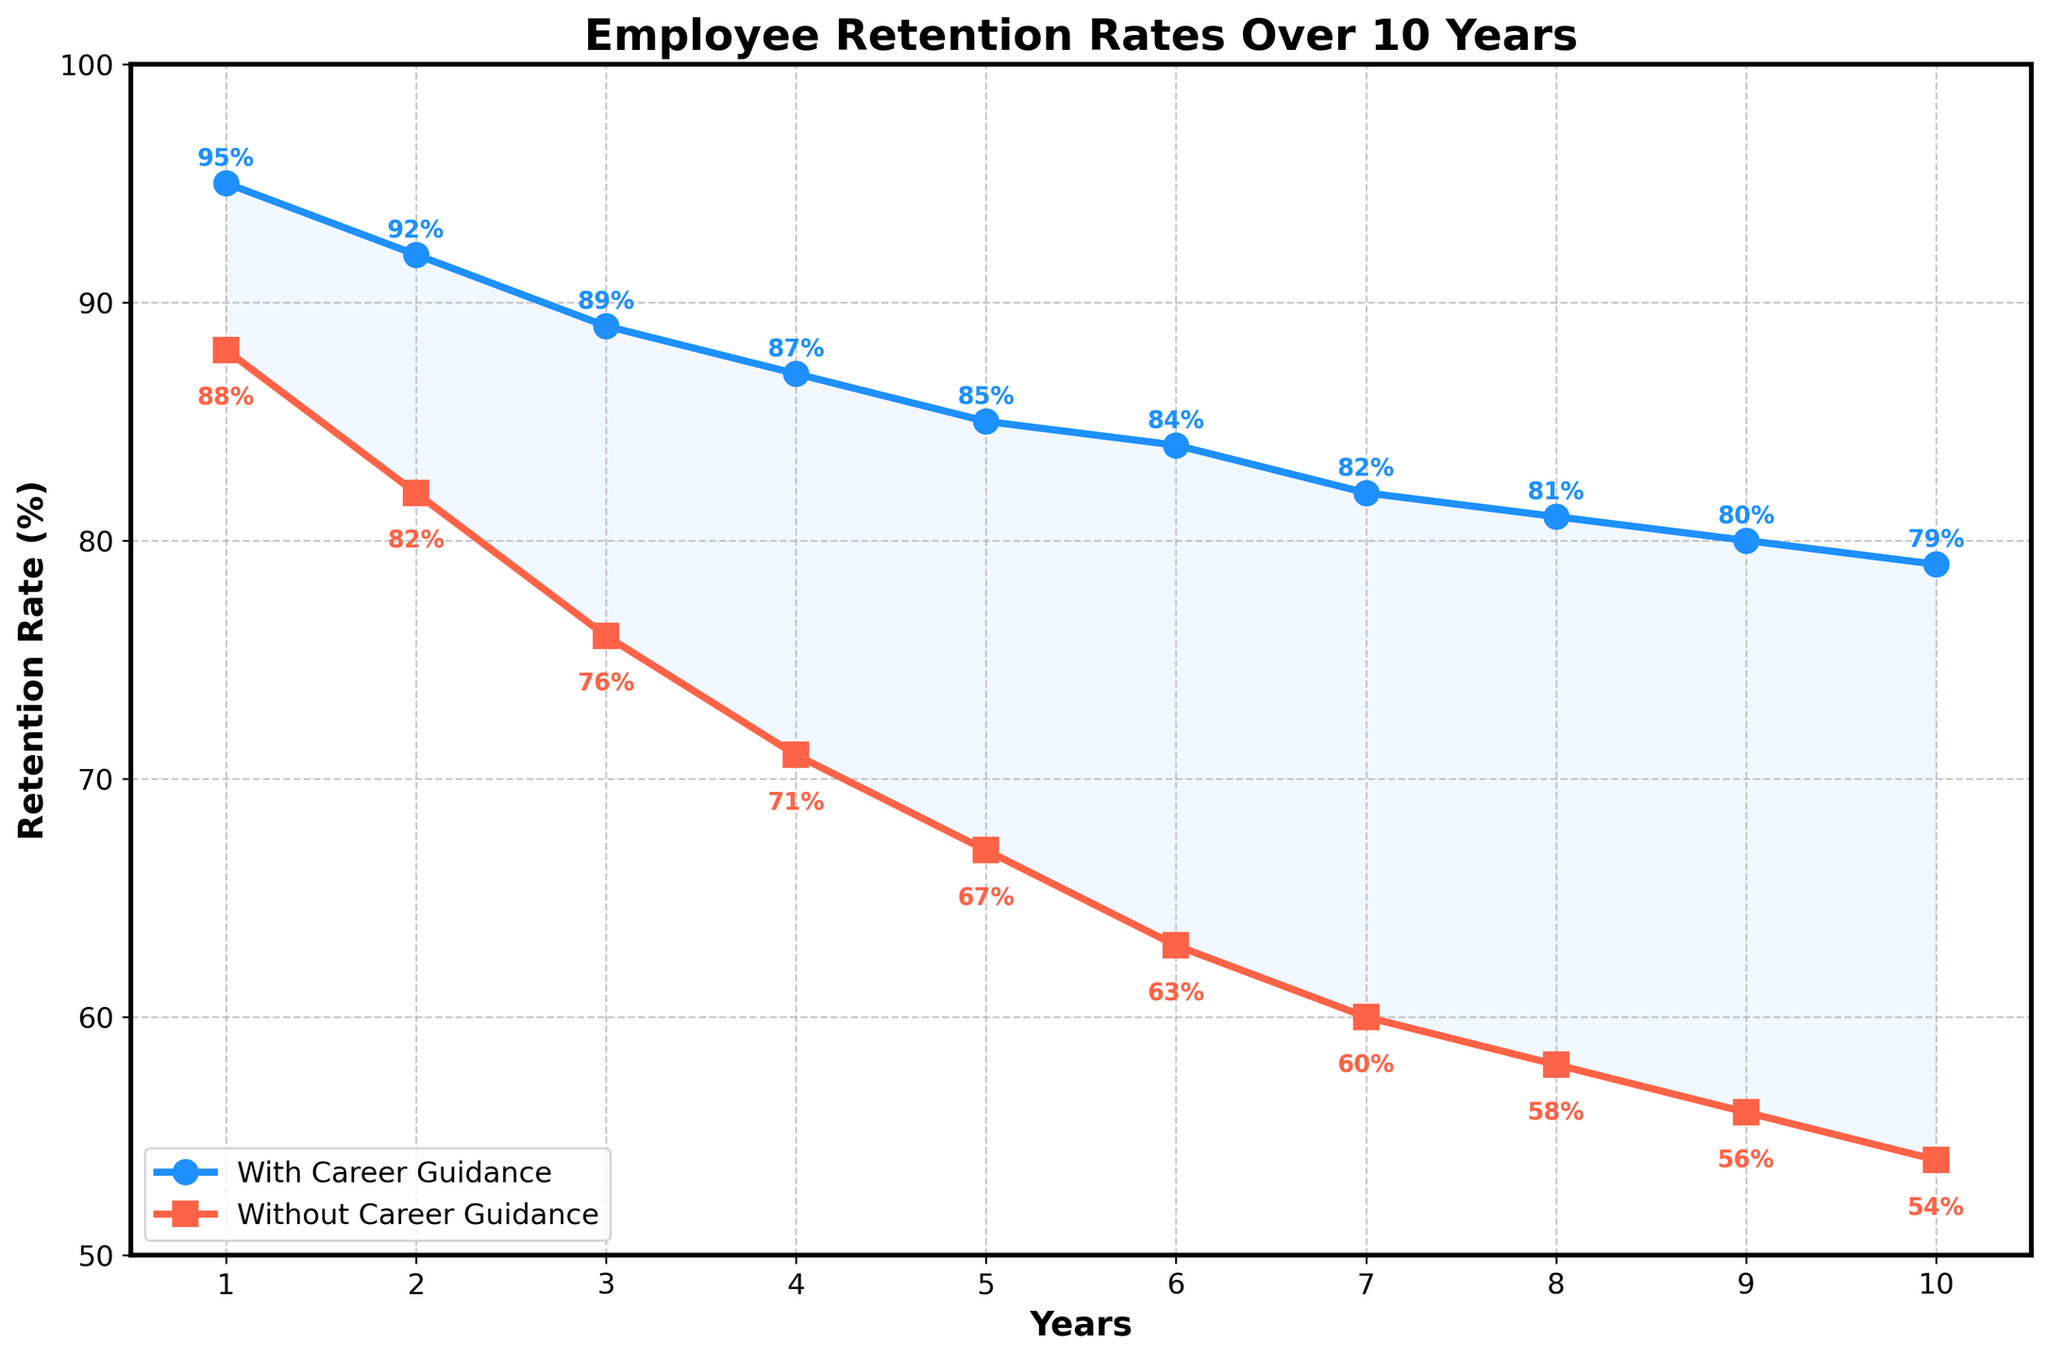Which year shows the highest retention rate for employees without career guidance? By looking at the line representing employees without career guidance, the highest point corresponds to the first year. The retention rate here is 88%.
Answer: Year 1 What is the difference in the retention rate between employees with career guidance and those without in Year 5? The retention rate for employees with career guidance in Year 5 is 85%, and for those without career guidance, it is 67%. The difference is 85 - 67.
Answer: 18% Which group showed a greater decrease in retention rates from Year 1 to Year 10? To find the decrease, subtract the retention rate in Year 10 from the retention rate in Year 1 for both groups. Employees with career guidance: 95% - 79% = 16%. Employees without career guidance: 88% - 54% = 34%.
Answer: Without career guidance In which year is the gap between the retention rates of the two groups the smallest? Check the difference in each year between the two groups' retention rates. The smallest gap is in Year 10, with 79% for those with guidance and 54% for those without, resulting in a difference of 25%.
Answer: Year 10 What percentage did the retention rate of employees without career guidance drop from Year 3 to Year 7? The retention rate for employees without career guidance was 76% in Year 3 and 60% in Year 7. The drop is 76% - 60%.
Answer: 16% Which year has the largest decline in retention rate for employees with career guidance compared to the previous year? By looking at the retention rates for each successive year for employees with career guidance, the year with the largest decline is from Year 2 to Year 3 (92% to 89%), a decline of 3%.
Answer: Year 3 On average, how much higher are the retention rates for employees with career guidance compared to those without over the 10 years? Find the difference for each year, sum them up, and then divide by the number of years. Differences: (95-88), (92-82), (89-76), (87-71), (85-67), (84-63), (82-60), (81-58), (80-56), (79-54). The sum is 124. Average = 124/10.
Answer: 12.4% By Year 5, what is the cumulative retention rate for employees with career guidance? Add the retention rates for employees with career guidance for the first five years: 95 + 92 + 89 + 87 + 85.
Answer: 448% Is there any point where the retention rate lines for employees with and without career guidance intersect? Visually inspect the plot to see if the blue line and red line intersect at any point. They do not intersect at any point in the 10-year period.
Answer: No 